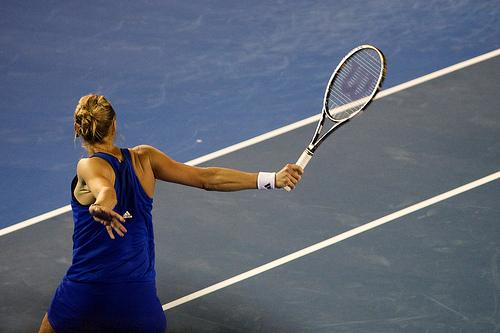Discuss the person's sports equipment and its appearance. The tennis player uses a black and white racket with a w inscription and a white handle. Write about the colors in the image and the objects they represent. The image features a blue court, white lines, a blue-shirted woman, and a black and white tennis racket. Talk about the ground of the tennis court and its appearance. The ground has blue and gray flooring with white lines on it, indicating a tennis court. Provide a concise description of the woman and the setting. A woman in an all-blue outfit and tied hair plays tennis on a blue and gray court with white lines. Give a brief overview of the entire scene. A blonde woman in a blue outfit is playing tennis, holding a racket with a white handle on a blue and gray court. Describe the woman's tennis outfit and accessories. The woman is wearing a dark blue sleeveless top, blue shorts, a white wrist guard, and a sweatband. Briefly describe the tennis racket and its features. The tennis racket has a white handle, a w inscription, and is black and white in color. State the person's appearance and attire in the image. The woman has tied hair, wears a sleeveless shirt, blue shorts, and a white wrist guard while holding a racket. Mention the person's stance and the object they're holding. The player holds a tennis racket in her right hand and is looking to the right side. Mention the main activity happening in the image and the person performing it. A woman wearing a blue outfit is playing tennis on a blue and gray court with white lines. 